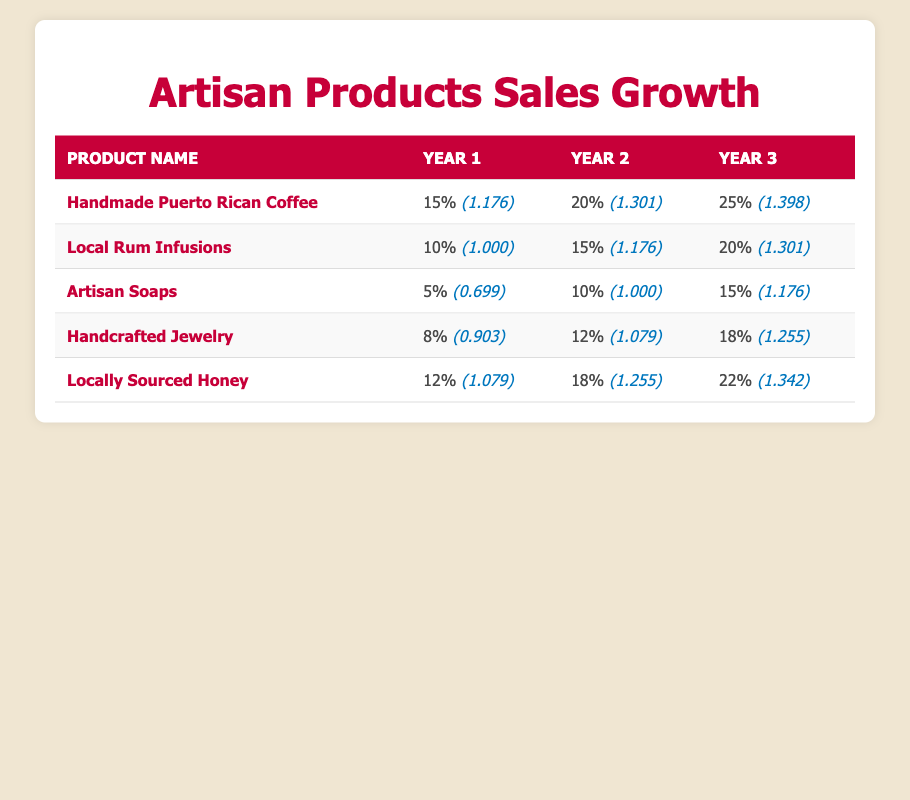What was the sales growth rate for Handmade Puerto Rican Coffee in Year 3? From the table, we directly find that for Handmade Puerto Rican Coffee, the sales growth rate in Year 3 is listed as 25%.
Answer: 25% Which artisan product had the highest sales growth rate in Year 2? By examining the sales growth rates in Year 2 for all products, we see 20% for Handmade Puerto Rican Coffee is the highest compared to others.
Answer: Handmade Puerto Rican Coffee What is the average sales growth rate for Locally Sourced Honey over the three years? First, we sum the sales growth rates: 12 + 18 + 22 = 52. Since there are three years, we divide the total by 3: 52 / 3 = approximately 17.33.
Answer: 17.33 Did Artisan Soaps have a sales growth rate of 10% in Year 2? According to the table, Artisan Soaps indeed had a sales growth rate of 10% in Year 2, which confirms the statement as true.
Answer: Yes What is the difference in sales growth rates between Year 3 and Year 1 for Handcrafted Jewelry? For Handcrafted Jewelry, the sales growth rate in Year 3 is 18% and in Year 1 is 8%. Calculating the difference: 18 - 8 = 10.
Answer: 10 Which product had the lowest logarithmic value in Year 1? Looking at the logarithmic values for Year 1, Artisan Soaps has the lowest value at 0.699.
Answer: Artisan Soaps If you combine the sales growth rates for Year 1 for all products, what is the total? Adding the Year 1 sales growth rates: 15 + 10 + 5 + 8 + 12 = 50 gives us the total growth rate.
Answer: 50 Is the sales growth rate of Local Rum Infusions the same in Year 1 and Year 2? From the table, Local Rum Infusions had a growth rate of 10% in Year 1 and 15% in Year 2, indicating they are not the same.
Answer: No Which product showed a consistent increase in sales growth rates over all three years? Observing the sales growth rates, we note that Handmade Puerto Rican Coffee had 15%, 20%, and 25%, showing a consistent increase.
Answer: Handmade Puerto Rican Coffee 